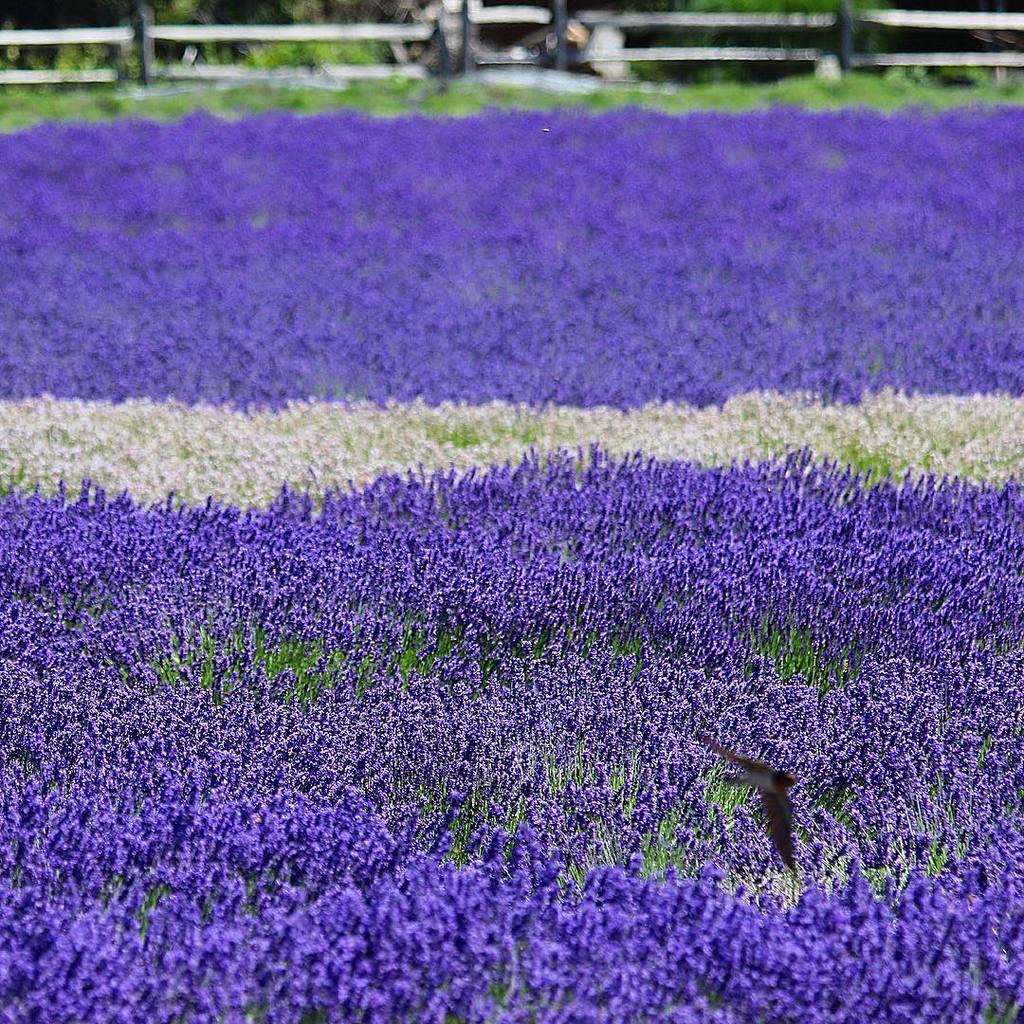In one or two sentences, can you explain what this image depicts? In the image there are violet and white color flowers. At the top of the image there is a fencing and also there are trees. 